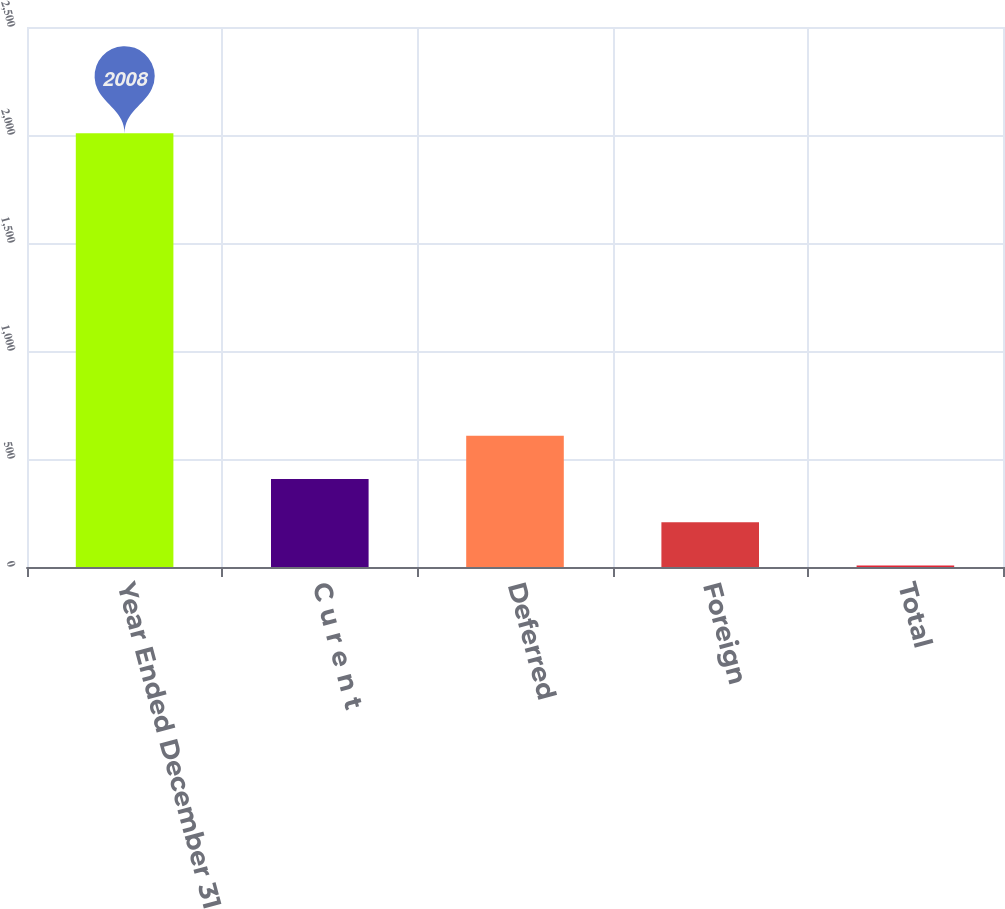<chart> <loc_0><loc_0><loc_500><loc_500><bar_chart><fcel>Year Ended December 31<fcel>C u r e n t<fcel>Deferred<fcel>Foreign<fcel>Total<nl><fcel>2008<fcel>407.2<fcel>607.3<fcel>207.1<fcel>7<nl></chart> 